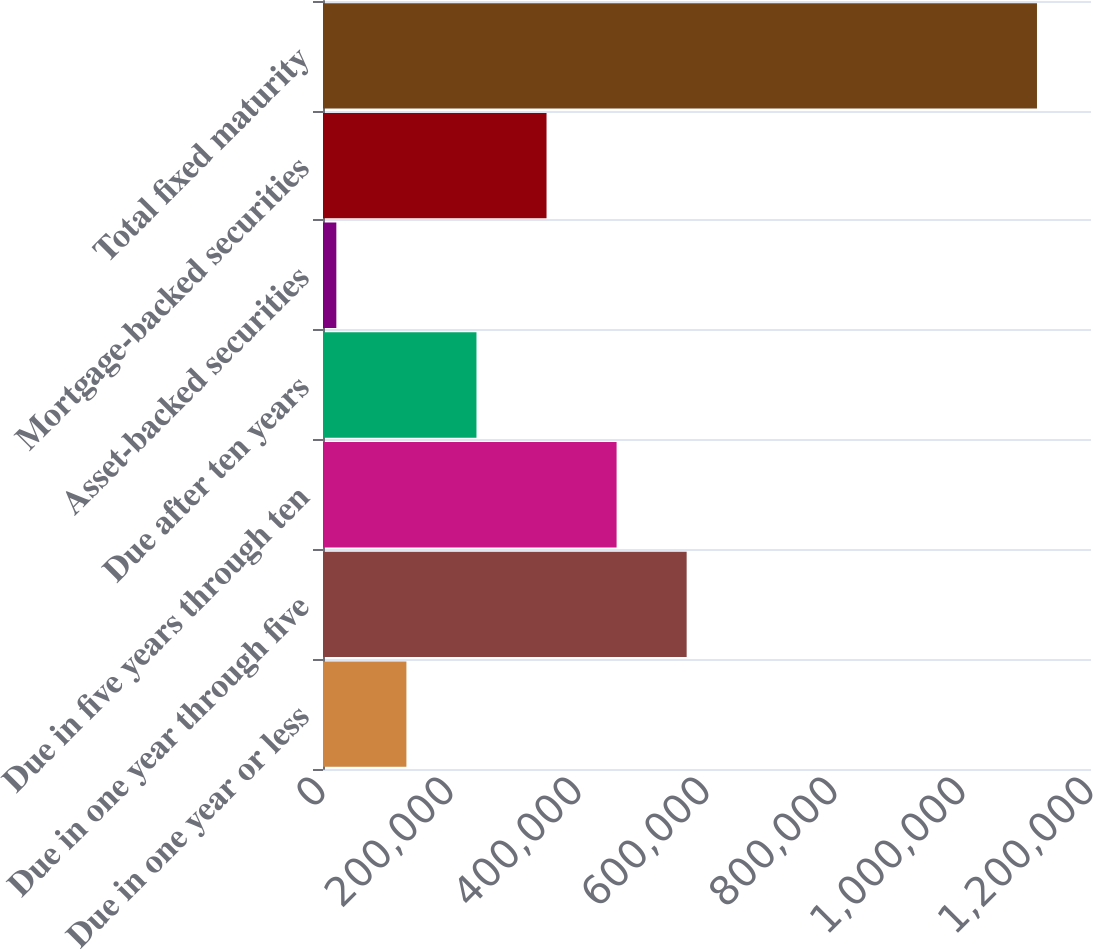Convert chart. <chart><loc_0><loc_0><loc_500><loc_500><bar_chart><fcel>Due in one year or less<fcel>Due in one year through five<fcel>Due in five years through ten<fcel>Due after ten years<fcel>Asset-backed securities<fcel>Mortgage-backed securities<fcel>Total fixed maturity<nl><fcel>130313<fcel>568210<fcel>458736<fcel>239788<fcel>20839<fcel>349262<fcel>1.11558e+06<nl></chart> 